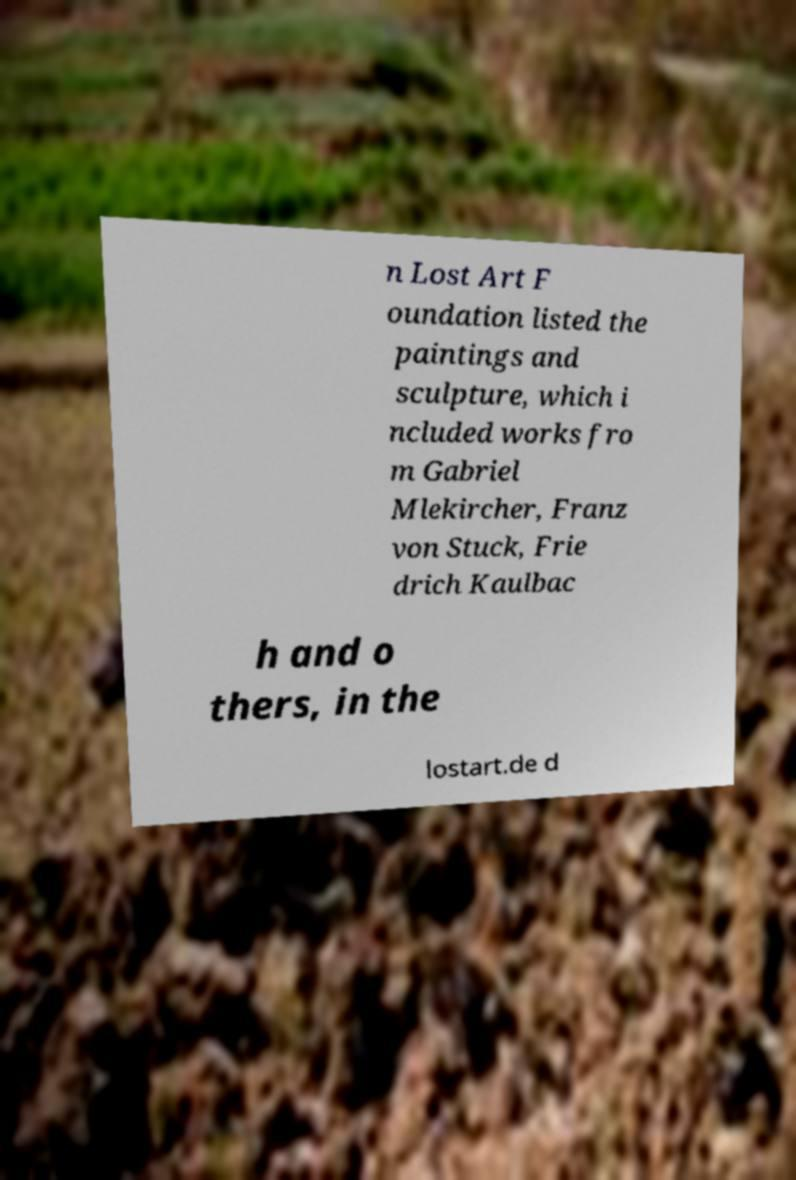Please read and relay the text visible in this image. What does it say? n Lost Art F oundation listed the paintings and sculpture, which i ncluded works fro m Gabriel Mlekircher, Franz von Stuck, Frie drich Kaulbac h and o thers, in the lostart.de d 